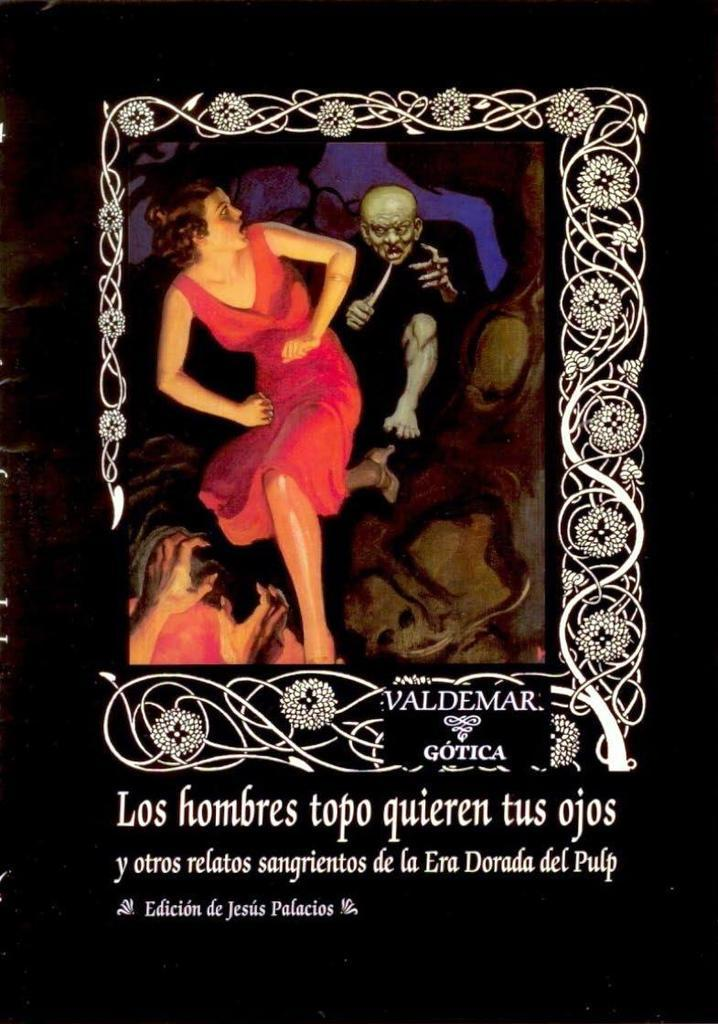What is present in the image that features a design or illustration? There is a poster in the image that has a design on it. What can be seen on the poster? There are people depicted on the poster, along with a design. Is there any text on the poster? Yes, there is text written on the poster. Can you see any rays coming from the lake in the image? There is no lake present in the image, so there are no rays coming from it. 